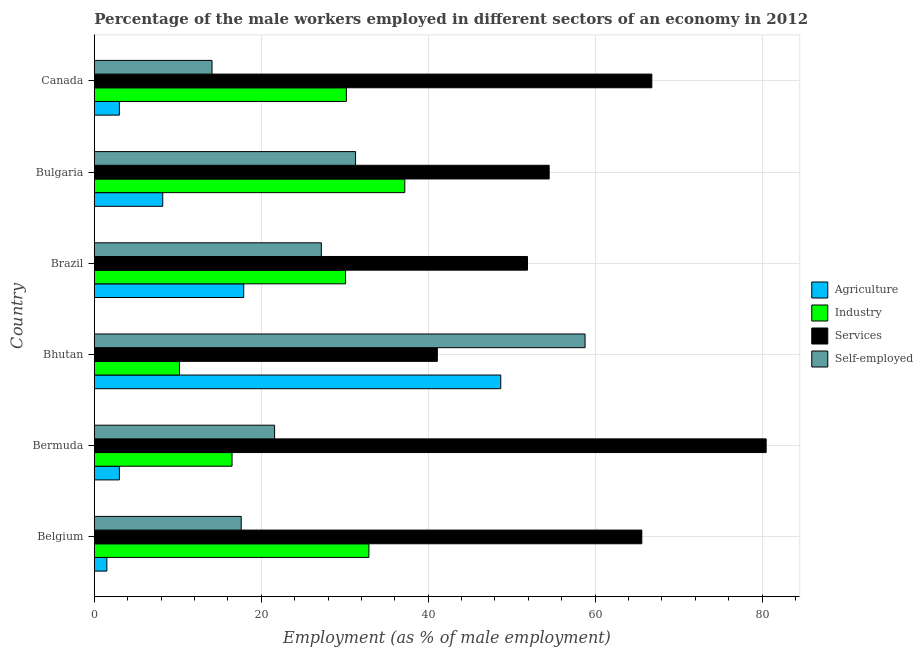How many different coloured bars are there?
Provide a succinct answer. 4. How many groups of bars are there?
Keep it short and to the point. 6. Are the number of bars on each tick of the Y-axis equal?
Provide a succinct answer. Yes. How many bars are there on the 6th tick from the top?
Provide a succinct answer. 4. What is the label of the 3rd group of bars from the top?
Your answer should be compact. Brazil. What is the percentage of male workers in industry in Bhutan?
Provide a short and direct response. 10.2. Across all countries, what is the maximum percentage of male workers in agriculture?
Your response must be concise. 48.7. Across all countries, what is the minimum percentage of male workers in services?
Keep it short and to the point. 41.1. In which country was the percentage of self employed male workers maximum?
Your response must be concise. Bhutan. In which country was the percentage of male workers in services minimum?
Your response must be concise. Bhutan. What is the total percentage of male workers in industry in the graph?
Make the answer very short. 157.1. What is the difference between the percentage of male workers in services in Bermuda and the percentage of self employed male workers in Canada?
Keep it short and to the point. 66.4. What is the average percentage of male workers in services per country?
Offer a terse response. 60.07. What is the difference between the percentage of male workers in services and percentage of male workers in industry in Belgium?
Make the answer very short. 32.7. What is the ratio of the percentage of self employed male workers in Bermuda to that in Canada?
Keep it short and to the point. 1.53. Is the percentage of self employed male workers in Bhutan less than that in Brazil?
Give a very brief answer. No. What is the difference between the highest and the second highest percentage of male workers in industry?
Offer a very short reply. 4.3. What is the difference between the highest and the lowest percentage of male workers in agriculture?
Offer a very short reply. 47.2. In how many countries, is the percentage of male workers in services greater than the average percentage of male workers in services taken over all countries?
Your answer should be compact. 3. Is it the case that in every country, the sum of the percentage of male workers in industry and percentage of male workers in agriculture is greater than the sum of percentage of male workers in services and percentage of self employed male workers?
Give a very brief answer. No. What does the 3rd bar from the top in Bhutan represents?
Make the answer very short. Industry. What does the 3rd bar from the bottom in Bulgaria represents?
Your response must be concise. Services. Is it the case that in every country, the sum of the percentage of male workers in agriculture and percentage of male workers in industry is greater than the percentage of male workers in services?
Your answer should be very brief. No. How many bars are there?
Keep it short and to the point. 24. Are all the bars in the graph horizontal?
Provide a succinct answer. Yes. How many countries are there in the graph?
Ensure brevity in your answer.  6. Does the graph contain grids?
Your answer should be compact. Yes. Where does the legend appear in the graph?
Ensure brevity in your answer.  Center right. How are the legend labels stacked?
Make the answer very short. Vertical. What is the title of the graph?
Offer a very short reply. Percentage of the male workers employed in different sectors of an economy in 2012. What is the label or title of the X-axis?
Give a very brief answer. Employment (as % of male employment). What is the label or title of the Y-axis?
Keep it short and to the point. Country. What is the Employment (as % of male employment) in Agriculture in Belgium?
Offer a very short reply. 1.5. What is the Employment (as % of male employment) of Industry in Belgium?
Your answer should be compact. 32.9. What is the Employment (as % of male employment) of Services in Belgium?
Your answer should be compact. 65.6. What is the Employment (as % of male employment) of Self-employed in Belgium?
Provide a short and direct response. 17.6. What is the Employment (as % of male employment) in Agriculture in Bermuda?
Ensure brevity in your answer.  3. What is the Employment (as % of male employment) in Services in Bermuda?
Offer a very short reply. 80.5. What is the Employment (as % of male employment) of Self-employed in Bermuda?
Offer a very short reply. 21.6. What is the Employment (as % of male employment) in Agriculture in Bhutan?
Ensure brevity in your answer.  48.7. What is the Employment (as % of male employment) in Industry in Bhutan?
Your response must be concise. 10.2. What is the Employment (as % of male employment) in Services in Bhutan?
Make the answer very short. 41.1. What is the Employment (as % of male employment) of Self-employed in Bhutan?
Your answer should be compact. 58.8. What is the Employment (as % of male employment) of Agriculture in Brazil?
Your response must be concise. 17.9. What is the Employment (as % of male employment) in Industry in Brazil?
Ensure brevity in your answer.  30.1. What is the Employment (as % of male employment) of Services in Brazil?
Provide a succinct answer. 51.9. What is the Employment (as % of male employment) in Self-employed in Brazil?
Provide a short and direct response. 27.2. What is the Employment (as % of male employment) in Agriculture in Bulgaria?
Provide a short and direct response. 8.2. What is the Employment (as % of male employment) of Industry in Bulgaria?
Offer a terse response. 37.2. What is the Employment (as % of male employment) of Services in Bulgaria?
Your answer should be compact. 54.5. What is the Employment (as % of male employment) of Self-employed in Bulgaria?
Keep it short and to the point. 31.3. What is the Employment (as % of male employment) in Industry in Canada?
Your answer should be very brief. 30.2. What is the Employment (as % of male employment) in Services in Canada?
Offer a terse response. 66.8. What is the Employment (as % of male employment) of Self-employed in Canada?
Ensure brevity in your answer.  14.1. Across all countries, what is the maximum Employment (as % of male employment) in Agriculture?
Your answer should be very brief. 48.7. Across all countries, what is the maximum Employment (as % of male employment) in Industry?
Your response must be concise. 37.2. Across all countries, what is the maximum Employment (as % of male employment) in Services?
Provide a short and direct response. 80.5. Across all countries, what is the maximum Employment (as % of male employment) of Self-employed?
Your answer should be compact. 58.8. Across all countries, what is the minimum Employment (as % of male employment) in Agriculture?
Offer a terse response. 1.5. Across all countries, what is the minimum Employment (as % of male employment) of Industry?
Make the answer very short. 10.2. Across all countries, what is the minimum Employment (as % of male employment) in Services?
Offer a terse response. 41.1. Across all countries, what is the minimum Employment (as % of male employment) of Self-employed?
Ensure brevity in your answer.  14.1. What is the total Employment (as % of male employment) in Agriculture in the graph?
Ensure brevity in your answer.  82.3. What is the total Employment (as % of male employment) of Industry in the graph?
Make the answer very short. 157.1. What is the total Employment (as % of male employment) of Services in the graph?
Provide a short and direct response. 360.4. What is the total Employment (as % of male employment) in Self-employed in the graph?
Your answer should be very brief. 170.6. What is the difference between the Employment (as % of male employment) in Agriculture in Belgium and that in Bermuda?
Ensure brevity in your answer.  -1.5. What is the difference between the Employment (as % of male employment) in Services in Belgium and that in Bermuda?
Ensure brevity in your answer.  -14.9. What is the difference between the Employment (as % of male employment) of Self-employed in Belgium and that in Bermuda?
Your answer should be very brief. -4. What is the difference between the Employment (as % of male employment) in Agriculture in Belgium and that in Bhutan?
Offer a terse response. -47.2. What is the difference between the Employment (as % of male employment) of Industry in Belgium and that in Bhutan?
Your answer should be compact. 22.7. What is the difference between the Employment (as % of male employment) of Self-employed in Belgium and that in Bhutan?
Make the answer very short. -41.2. What is the difference between the Employment (as % of male employment) of Agriculture in Belgium and that in Brazil?
Ensure brevity in your answer.  -16.4. What is the difference between the Employment (as % of male employment) in Services in Belgium and that in Brazil?
Make the answer very short. 13.7. What is the difference between the Employment (as % of male employment) of Agriculture in Belgium and that in Bulgaria?
Make the answer very short. -6.7. What is the difference between the Employment (as % of male employment) of Industry in Belgium and that in Bulgaria?
Your answer should be compact. -4.3. What is the difference between the Employment (as % of male employment) in Self-employed in Belgium and that in Bulgaria?
Give a very brief answer. -13.7. What is the difference between the Employment (as % of male employment) in Agriculture in Bermuda and that in Bhutan?
Provide a short and direct response. -45.7. What is the difference between the Employment (as % of male employment) in Industry in Bermuda and that in Bhutan?
Provide a succinct answer. 6.3. What is the difference between the Employment (as % of male employment) of Services in Bermuda and that in Bhutan?
Keep it short and to the point. 39.4. What is the difference between the Employment (as % of male employment) in Self-employed in Bermuda and that in Bhutan?
Your response must be concise. -37.2. What is the difference between the Employment (as % of male employment) in Agriculture in Bermuda and that in Brazil?
Your answer should be very brief. -14.9. What is the difference between the Employment (as % of male employment) of Services in Bermuda and that in Brazil?
Offer a terse response. 28.6. What is the difference between the Employment (as % of male employment) in Agriculture in Bermuda and that in Bulgaria?
Your response must be concise. -5.2. What is the difference between the Employment (as % of male employment) of Industry in Bermuda and that in Bulgaria?
Offer a very short reply. -20.7. What is the difference between the Employment (as % of male employment) in Industry in Bermuda and that in Canada?
Offer a terse response. -13.7. What is the difference between the Employment (as % of male employment) of Services in Bermuda and that in Canada?
Offer a very short reply. 13.7. What is the difference between the Employment (as % of male employment) in Agriculture in Bhutan and that in Brazil?
Your response must be concise. 30.8. What is the difference between the Employment (as % of male employment) in Industry in Bhutan and that in Brazil?
Keep it short and to the point. -19.9. What is the difference between the Employment (as % of male employment) in Services in Bhutan and that in Brazil?
Provide a succinct answer. -10.8. What is the difference between the Employment (as % of male employment) in Self-employed in Bhutan and that in Brazil?
Your answer should be compact. 31.6. What is the difference between the Employment (as % of male employment) in Agriculture in Bhutan and that in Bulgaria?
Give a very brief answer. 40.5. What is the difference between the Employment (as % of male employment) of Industry in Bhutan and that in Bulgaria?
Your response must be concise. -27. What is the difference between the Employment (as % of male employment) of Services in Bhutan and that in Bulgaria?
Your answer should be compact. -13.4. What is the difference between the Employment (as % of male employment) of Agriculture in Bhutan and that in Canada?
Keep it short and to the point. 45.7. What is the difference between the Employment (as % of male employment) of Industry in Bhutan and that in Canada?
Provide a succinct answer. -20. What is the difference between the Employment (as % of male employment) in Services in Bhutan and that in Canada?
Keep it short and to the point. -25.7. What is the difference between the Employment (as % of male employment) in Self-employed in Bhutan and that in Canada?
Offer a very short reply. 44.7. What is the difference between the Employment (as % of male employment) of Agriculture in Brazil and that in Canada?
Provide a succinct answer. 14.9. What is the difference between the Employment (as % of male employment) of Industry in Brazil and that in Canada?
Make the answer very short. -0.1. What is the difference between the Employment (as % of male employment) of Services in Brazil and that in Canada?
Offer a very short reply. -14.9. What is the difference between the Employment (as % of male employment) in Self-employed in Brazil and that in Canada?
Provide a short and direct response. 13.1. What is the difference between the Employment (as % of male employment) of Services in Bulgaria and that in Canada?
Offer a very short reply. -12.3. What is the difference between the Employment (as % of male employment) of Self-employed in Bulgaria and that in Canada?
Give a very brief answer. 17.2. What is the difference between the Employment (as % of male employment) of Agriculture in Belgium and the Employment (as % of male employment) of Industry in Bermuda?
Make the answer very short. -15. What is the difference between the Employment (as % of male employment) in Agriculture in Belgium and the Employment (as % of male employment) in Services in Bermuda?
Give a very brief answer. -79. What is the difference between the Employment (as % of male employment) of Agriculture in Belgium and the Employment (as % of male employment) of Self-employed in Bermuda?
Provide a succinct answer. -20.1. What is the difference between the Employment (as % of male employment) in Industry in Belgium and the Employment (as % of male employment) in Services in Bermuda?
Your response must be concise. -47.6. What is the difference between the Employment (as % of male employment) of Services in Belgium and the Employment (as % of male employment) of Self-employed in Bermuda?
Your answer should be compact. 44. What is the difference between the Employment (as % of male employment) in Agriculture in Belgium and the Employment (as % of male employment) in Services in Bhutan?
Keep it short and to the point. -39.6. What is the difference between the Employment (as % of male employment) in Agriculture in Belgium and the Employment (as % of male employment) in Self-employed in Bhutan?
Provide a short and direct response. -57.3. What is the difference between the Employment (as % of male employment) in Industry in Belgium and the Employment (as % of male employment) in Self-employed in Bhutan?
Your answer should be compact. -25.9. What is the difference between the Employment (as % of male employment) of Agriculture in Belgium and the Employment (as % of male employment) of Industry in Brazil?
Offer a terse response. -28.6. What is the difference between the Employment (as % of male employment) in Agriculture in Belgium and the Employment (as % of male employment) in Services in Brazil?
Provide a succinct answer. -50.4. What is the difference between the Employment (as % of male employment) in Agriculture in Belgium and the Employment (as % of male employment) in Self-employed in Brazil?
Provide a short and direct response. -25.7. What is the difference between the Employment (as % of male employment) of Industry in Belgium and the Employment (as % of male employment) of Services in Brazil?
Your answer should be compact. -19. What is the difference between the Employment (as % of male employment) in Industry in Belgium and the Employment (as % of male employment) in Self-employed in Brazil?
Make the answer very short. 5.7. What is the difference between the Employment (as % of male employment) in Services in Belgium and the Employment (as % of male employment) in Self-employed in Brazil?
Offer a very short reply. 38.4. What is the difference between the Employment (as % of male employment) of Agriculture in Belgium and the Employment (as % of male employment) of Industry in Bulgaria?
Your answer should be very brief. -35.7. What is the difference between the Employment (as % of male employment) in Agriculture in Belgium and the Employment (as % of male employment) in Services in Bulgaria?
Give a very brief answer. -53. What is the difference between the Employment (as % of male employment) of Agriculture in Belgium and the Employment (as % of male employment) of Self-employed in Bulgaria?
Offer a very short reply. -29.8. What is the difference between the Employment (as % of male employment) of Industry in Belgium and the Employment (as % of male employment) of Services in Bulgaria?
Make the answer very short. -21.6. What is the difference between the Employment (as % of male employment) in Services in Belgium and the Employment (as % of male employment) in Self-employed in Bulgaria?
Your answer should be compact. 34.3. What is the difference between the Employment (as % of male employment) in Agriculture in Belgium and the Employment (as % of male employment) in Industry in Canada?
Provide a short and direct response. -28.7. What is the difference between the Employment (as % of male employment) of Agriculture in Belgium and the Employment (as % of male employment) of Services in Canada?
Offer a terse response. -65.3. What is the difference between the Employment (as % of male employment) in Industry in Belgium and the Employment (as % of male employment) in Services in Canada?
Your response must be concise. -33.9. What is the difference between the Employment (as % of male employment) in Industry in Belgium and the Employment (as % of male employment) in Self-employed in Canada?
Provide a short and direct response. 18.8. What is the difference between the Employment (as % of male employment) in Services in Belgium and the Employment (as % of male employment) in Self-employed in Canada?
Keep it short and to the point. 51.5. What is the difference between the Employment (as % of male employment) of Agriculture in Bermuda and the Employment (as % of male employment) of Industry in Bhutan?
Your response must be concise. -7.2. What is the difference between the Employment (as % of male employment) of Agriculture in Bermuda and the Employment (as % of male employment) of Services in Bhutan?
Give a very brief answer. -38.1. What is the difference between the Employment (as % of male employment) in Agriculture in Bermuda and the Employment (as % of male employment) in Self-employed in Bhutan?
Ensure brevity in your answer.  -55.8. What is the difference between the Employment (as % of male employment) in Industry in Bermuda and the Employment (as % of male employment) in Services in Bhutan?
Your response must be concise. -24.6. What is the difference between the Employment (as % of male employment) of Industry in Bermuda and the Employment (as % of male employment) of Self-employed in Bhutan?
Offer a terse response. -42.3. What is the difference between the Employment (as % of male employment) in Services in Bermuda and the Employment (as % of male employment) in Self-employed in Bhutan?
Keep it short and to the point. 21.7. What is the difference between the Employment (as % of male employment) of Agriculture in Bermuda and the Employment (as % of male employment) of Industry in Brazil?
Keep it short and to the point. -27.1. What is the difference between the Employment (as % of male employment) of Agriculture in Bermuda and the Employment (as % of male employment) of Services in Brazil?
Make the answer very short. -48.9. What is the difference between the Employment (as % of male employment) in Agriculture in Bermuda and the Employment (as % of male employment) in Self-employed in Brazil?
Make the answer very short. -24.2. What is the difference between the Employment (as % of male employment) in Industry in Bermuda and the Employment (as % of male employment) in Services in Brazil?
Offer a terse response. -35.4. What is the difference between the Employment (as % of male employment) of Services in Bermuda and the Employment (as % of male employment) of Self-employed in Brazil?
Provide a succinct answer. 53.3. What is the difference between the Employment (as % of male employment) of Agriculture in Bermuda and the Employment (as % of male employment) of Industry in Bulgaria?
Your response must be concise. -34.2. What is the difference between the Employment (as % of male employment) in Agriculture in Bermuda and the Employment (as % of male employment) in Services in Bulgaria?
Your response must be concise. -51.5. What is the difference between the Employment (as % of male employment) in Agriculture in Bermuda and the Employment (as % of male employment) in Self-employed in Bulgaria?
Provide a succinct answer. -28.3. What is the difference between the Employment (as % of male employment) in Industry in Bermuda and the Employment (as % of male employment) in Services in Bulgaria?
Keep it short and to the point. -38. What is the difference between the Employment (as % of male employment) of Industry in Bermuda and the Employment (as % of male employment) of Self-employed in Bulgaria?
Provide a succinct answer. -14.8. What is the difference between the Employment (as % of male employment) in Services in Bermuda and the Employment (as % of male employment) in Self-employed in Bulgaria?
Provide a succinct answer. 49.2. What is the difference between the Employment (as % of male employment) in Agriculture in Bermuda and the Employment (as % of male employment) in Industry in Canada?
Make the answer very short. -27.2. What is the difference between the Employment (as % of male employment) of Agriculture in Bermuda and the Employment (as % of male employment) of Services in Canada?
Provide a short and direct response. -63.8. What is the difference between the Employment (as % of male employment) in Industry in Bermuda and the Employment (as % of male employment) in Services in Canada?
Give a very brief answer. -50.3. What is the difference between the Employment (as % of male employment) in Industry in Bermuda and the Employment (as % of male employment) in Self-employed in Canada?
Give a very brief answer. 2.4. What is the difference between the Employment (as % of male employment) of Services in Bermuda and the Employment (as % of male employment) of Self-employed in Canada?
Offer a terse response. 66.4. What is the difference between the Employment (as % of male employment) in Industry in Bhutan and the Employment (as % of male employment) in Services in Brazil?
Provide a succinct answer. -41.7. What is the difference between the Employment (as % of male employment) in Industry in Bhutan and the Employment (as % of male employment) in Self-employed in Brazil?
Keep it short and to the point. -17. What is the difference between the Employment (as % of male employment) in Services in Bhutan and the Employment (as % of male employment) in Self-employed in Brazil?
Your response must be concise. 13.9. What is the difference between the Employment (as % of male employment) in Agriculture in Bhutan and the Employment (as % of male employment) in Self-employed in Bulgaria?
Provide a succinct answer. 17.4. What is the difference between the Employment (as % of male employment) of Industry in Bhutan and the Employment (as % of male employment) of Services in Bulgaria?
Your response must be concise. -44.3. What is the difference between the Employment (as % of male employment) in Industry in Bhutan and the Employment (as % of male employment) in Self-employed in Bulgaria?
Provide a short and direct response. -21.1. What is the difference between the Employment (as % of male employment) of Agriculture in Bhutan and the Employment (as % of male employment) of Industry in Canada?
Make the answer very short. 18.5. What is the difference between the Employment (as % of male employment) of Agriculture in Bhutan and the Employment (as % of male employment) of Services in Canada?
Offer a terse response. -18.1. What is the difference between the Employment (as % of male employment) of Agriculture in Bhutan and the Employment (as % of male employment) of Self-employed in Canada?
Offer a very short reply. 34.6. What is the difference between the Employment (as % of male employment) in Industry in Bhutan and the Employment (as % of male employment) in Services in Canada?
Offer a terse response. -56.6. What is the difference between the Employment (as % of male employment) in Industry in Bhutan and the Employment (as % of male employment) in Self-employed in Canada?
Your answer should be compact. -3.9. What is the difference between the Employment (as % of male employment) in Services in Bhutan and the Employment (as % of male employment) in Self-employed in Canada?
Keep it short and to the point. 27. What is the difference between the Employment (as % of male employment) of Agriculture in Brazil and the Employment (as % of male employment) of Industry in Bulgaria?
Offer a very short reply. -19.3. What is the difference between the Employment (as % of male employment) of Agriculture in Brazil and the Employment (as % of male employment) of Services in Bulgaria?
Provide a short and direct response. -36.6. What is the difference between the Employment (as % of male employment) in Industry in Brazil and the Employment (as % of male employment) in Services in Bulgaria?
Your answer should be very brief. -24.4. What is the difference between the Employment (as % of male employment) of Industry in Brazil and the Employment (as % of male employment) of Self-employed in Bulgaria?
Provide a succinct answer. -1.2. What is the difference between the Employment (as % of male employment) in Services in Brazil and the Employment (as % of male employment) in Self-employed in Bulgaria?
Provide a succinct answer. 20.6. What is the difference between the Employment (as % of male employment) in Agriculture in Brazil and the Employment (as % of male employment) in Industry in Canada?
Make the answer very short. -12.3. What is the difference between the Employment (as % of male employment) of Agriculture in Brazil and the Employment (as % of male employment) of Services in Canada?
Provide a short and direct response. -48.9. What is the difference between the Employment (as % of male employment) of Agriculture in Brazil and the Employment (as % of male employment) of Self-employed in Canada?
Ensure brevity in your answer.  3.8. What is the difference between the Employment (as % of male employment) in Industry in Brazil and the Employment (as % of male employment) in Services in Canada?
Your response must be concise. -36.7. What is the difference between the Employment (as % of male employment) of Industry in Brazil and the Employment (as % of male employment) of Self-employed in Canada?
Your response must be concise. 16. What is the difference between the Employment (as % of male employment) in Services in Brazil and the Employment (as % of male employment) in Self-employed in Canada?
Provide a short and direct response. 37.8. What is the difference between the Employment (as % of male employment) in Agriculture in Bulgaria and the Employment (as % of male employment) in Services in Canada?
Provide a short and direct response. -58.6. What is the difference between the Employment (as % of male employment) in Industry in Bulgaria and the Employment (as % of male employment) in Services in Canada?
Your answer should be compact. -29.6. What is the difference between the Employment (as % of male employment) of Industry in Bulgaria and the Employment (as % of male employment) of Self-employed in Canada?
Offer a very short reply. 23.1. What is the difference between the Employment (as % of male employment) in Services in Bulgaria and the Employment (as % of male employment) in Self-employed in Canada?
Your answer should be very brief. 40.4. What is the average Employment (as % of male employment) in Agriculture per country?
Your answer should be compact. 13.72. What is the average Employment (as % of male employment) of Industry per country?
Provide a succinct answer. 26.18. What is the average Employment (as % of male employment) in Services per country?
Offer a very short reply. 60.07. What is the average Employment (as % of male employment) in Self-employed per country?
Give a very brief answer. 28.43. What is the difference between the Employment (as % of male employment) in Agriculture and Employment (as % of male employment) in Industry in Belgium?
Keep it short and to the point. -31.4. What is the difference between the Employment (as % of male employment) in Agriculture and Employment (as % of male employment) in Services in Belgium?
Ensure brevity in your answer.  -64.1. What is the difference between the Employment (as % of male employment) in Agriculture and Employment (as % of male employment) in Self-employed in Belgium?
Your answer should be compact. -16.1. What is the difference between the Employment (as % of male employment) of Industry and Employment (as % of male employment) of Services in Belgium?
Offer a very short reply. -32.7. What is the difference between the Employment (as % of male employment) of Industry and Employment (as % of male employment) of Self-employed in Belgium?
Your response must be concise. 15.3. What is the difference between the Employment (as % of male employment) of Services and Employment (as % of male employment) of Self-employed in Belgium?
Offer a very short reply. 48. What is the difference between the Employment (as % of male employment) of Agriculture and Employment (as % of male employment) of Services in Bermuda?
Offer a very short reply. -77.5. What is the difference between the Employment (as % of male employment) of Agriculture and Employment (as % of male employment) of Self-employed in Bermuda?
Keep it short and to the point. -18.6. What is the difference between the Employment (as % of male employment) in Industry and Employment (as % of male employment) in Services in Bermuda?
Your answer should be compact. -64. What is the difference between the Employment (as % of male employment) in Services and Employment (as % of male employment) in Self-employed in Bermuda?
Keep it short and to the point. 58.9. What is the difference between the Employment (as % of male employment) of Agriculture and Employment (as % of male employment) of Industry in Bhutan?
Offer a very short reply. 38.5. What is the difference between the Employment (as % of male employment) in Agriculture and Employment (as % of male employment) in Services in Bhutan?
Provide a succinct answer. 7.6. What is the difference between the Employment (as % of male employment) in Agriculture and Employment (as % of male employment) in Self-employed in Bhutan?
Your answer should be very brief. -10.1. What is the difference between the Employment (as % of male employment) in Industry and Employment (as % of male employment) in Services in Bhutan?
Ensure brevity in your answer.  -30.9. What is the difference between the Employment (as % of male employment) in Industry and Employment (as % of male employment) in Self-employed in Bhutan?
Your answer should be compact. -48.6. What is the difference between the Employment (as % of male employment) of Services and Employment (as % of male employment) of Self-employed in Bhutan?
Provide a succinct answer. -17.7. What is the difference between the Employment (as % of male employment) in Agriculture and Employment (as % of male employment) in Industry in Brazil?
Offer a terse response. -12.2. What is the difference between the Employment (as % of male employment) in Agriculture and Employment (as % of male employment) in Services in Brazil?
Make the answer very short. -34. What is the difference between the Employment (as % of male employment) of Agriculture and Employment (as % of male employment) of Self-employed in Brazil?
Provide a short and direct response. -9.3. What is the difference between the Employment (as % of male employment) in Industry and Employment (as % of male employment) in Services in Brazil?
Your response must be concise. -21.8. What is the difference between the Employment (as % of male employment) of Services and Employment (as % of male employment) of Self-employed in Brazil?
Keep it short and to the point. 24.7. What is the difference between the Employment (as % of male employment) of Agriculture and Employment (as % of male employment) of Services in Bulgaria?
Provide a succinct answer. -46.3. What is the difference between the Employment (as % of male employment) of Agriculture and Employment (as % of male employment) of Self-employed in Bulgaria?
Offer a very short reply. -23.1. What is the difference between the Employment (as % of male employment) of Industry and Employment (as % of male employment) of Services in Bulgaria?
Make the answer very short. -17.3. What is the difference between the Employment (as % of male employment) of Services and Employment (as % of male employment) of Self-employed in Bulgaria?
Offer a terse response. 23.2. What is the difference between the Employment (as % of male employment) in Agriculture and Employment (as % of male employment) in Industry in Canada?
Give a very brief answer. -27.2. What is the difference between the Employment (as % of male employment) in Agriculture and Employment (as % of male employment) in Services in Canada?
Your answer should be compact. -63.8. What is the difference between the Employment (as % of male employment) of Industry and Employment (as % of male employment) of Services in Canada?
Offer a terse response. -36.6. What is the difference between the Employment (as % of male employment) in Services and Employment (as % of male employment) in Self-employed in Canada?
Keep it short and to the point. 52.7. What is the ratio of the Employment (as % of male employment) in Industry in Belgium to that in Bermuda?
Provide a short and direct response. 1.99. What is the ratio of the Employment (as % of male employment) of Services in Belgium to that in Bermuda?
Offer a terse response. 0.81. What is the ratio of the Employment (as % of male employment) in Self-employed in Belgium to that in Bermuda?
Provide a succinct answer. 0.81. What is the ratio of the Employment (as % of male employment) of Agriculture in Belgium to that in Bhutan?
Keep it short and to the point. 0.03. What is the ratio of the Employment (as % of male employment) of Industry in Belgium to that in Bhutan?
Make the answer very short. 3.23. What is the ratio of the Employment (as % of male employment) in Services in Belgium to that in Bhutan?
Ensure brevity in your answer.  1.6. What is the ratio of the Employment (as % of male employment) in Self-employed in Belgium to that in Bhutan?
Provide a succinct answer. 0.3. What is the ratio of the Employment (as % of male employment) in Agriculture in Belgium to that in Brazil?
Offer a terse response. 0.08. What is the ratio of the Employment (as % of male employment) of Industry in Belgium to that in Brazil?
Keep it short and to the point. 1.09. What is the ratio of the Employment (as % of male employment) of Services in Belgium to that in Brazil?
Give a very brief answer. 1.26. What is the ratio of the Employment (as % of male employment) in Self-employed in Belgium to that in Brazil?
Your answer should be compact. 0.65. What is the ratio of the Employment (as % of male employment) of Agriculture in Belgium to that in Bulgaria?
Make the answer very short. 0.18. What is the ratio of the Employment (as % of male employment) of Industry in Belgium to that in Bulgaria?
Keep it short and to the point. 0.88. What is the ratio of the Employment (as % of male employment) in Services in Belgium to that in Bulgaria?
Your answer should be very brief. 1.2. What is the ratio of the Employment (as % of male employment) in Self-employed in Belgium to that in Bulgaria?
Your answer should be compact. 0.56. What is the ratio of the Employment (as % of male employment) in Industry in Belgium to that in Canada?
Make the answer very short. 1.09. What is the ratio of the Employment (as % of male employment) of Self-employed in Belgium to that in Canada?
Provide a short and direct response. 1.25. What is the ratio of the Employment (as % of male employment) of Agriculture in Bermuda to that in Bhutan?
Make the answer very short. 0.06. What is the ratio of the Employment (as % of male employment) of Industry in Bermuda to that in Bhutan?
Make the answer very short. 1.62. What is the ratio of the Employment (as % of male employment) in Services in Bermuda to that in Bhutan?
Your answer should be compact. 1.96. What is the ratio of the Employment (as % of male employment) in Self-employed in Bermuda to that in Bhutan?
Offer a terse response. 0.37. What is the ratio of the Employment (as % of male employment) in Agriculture in Bermuda to that in Brazil?
Make the answer very short. 0.17. What is the ratio of the Employment (as % of male employment) of Industry in Bermuda to that in Brazil?
Provide a succinct answer. 0.55. What is the ratio of the Employment (as % of male employment) of Services in Bermuda to that in Brazil?
Make the answer very short. 1.55. What is the ratio of the Employment (as % of male employment) of Self-employed in Bermuda to that in Brazil?
Give a very brief answer. 0.79. What is the ratio of the Employment (as % of male employment) of Agriculture in Bermuda to that in Bulgaria?
Make the answer very short. 0.37. What is the ratio of the Employment (as % of male employment) in Industry in Bermuda to that in Bulgaria?
Your response must be concise. 0.44. What is the ratio of the Employment (as % of male employment) of Services in Bermuda to that in Bulgaria?
Provide a short and direct response. 1.48. What is the ratio of the Employment (as % of male employment) of Self-employed in Bermuda to that in Bulgaria?
Provide a short and direct response. 0.69. What is the ratio of the Employment (as % of male employment) of Agriculture in Bermuda to that in Canada?
Keep it short and to the point. 1. What is the ratio of the Employment (as % of male employment) in Industry in Bermuda to that in Canada?
Ensure brevity in your answer.  0.55. What is the ratio of the Employment (as % of male employment) of Services in Bermuda to that in Canada?
Your answer should be very brief. 1.21. What is the ratio of the Employment (as % of male employment) of Self-employed in Bermuda to that in Canada?
Ensure brevity in your answer.  1.53. What is the ratio of the Employment (as % of male employment) of Agriculture in Bhutan to that in Brazil?
Offer a very short reply. 2.72. What is the ratio of the Employment (as % of male employment) in Industry in Bhutan to that in Brazil?
Give a very brief answer. 0.34. What is the ratio of the Employment (as % of male employment) of Services in Bhutan to that in Brazil?
Your answer should be very brief. 0.79. What is the ratio of the Employment (as % of male employment) of Self-employed in Bhutan to that in Brazil?
Your response must be concise. 2.16. What is the ratio of the Employment (as % of male employment) of Agriculture in Bhutan to that in Bulgaria?
Provide a short and direct response. 5.94. What is the ratio of the Employment (as % of male employment) in Industry in Bhutan to that in Bulgaria?
Provide a succinct answer. 0.27. What is the ratio of the Employment (as % of male employment) in Services in Bhutan to that in Bulgaria?
Give a very brief answer. 0.75. What is the ratio of the Employment (as % of male employment) in Self-employed in Bhutan to that in Bulgaria?
Your response must be concise. 1.88. What is the ratio of the Employment (as % of male employment) in Agriculture in Bhutan to that in Canada?
Your answer should be compact. 16.23. What is the ratio of the Employment (as % of male employment) of Industry in Bhutan to that in Canada?
Give a very brief answer. 0.34. What is the ratio of the Employment (as % of male employment) of Services in Bhutan to that in Canada?
Your answer should be very brief. 0.62. What is the ratio of the Employment (as % of male employment) in Self-employed in Bhutan to that in Canada?
Your response must be concise. 4.17. What is the ratio of the Employment (as % of male employment) of Agriculture in Brazil to that in Bulgaria?
Keep it short and to the point. 2.18. What is the ratio of the Employment (as % of male employment) of Industry in Brazil to that in Bulgaria?
Ensure brevity in your answer.  0.81. What is the ratio of the Employment (as % of male employment) in Services in Brazil to that in Bulgaria?
Offer a terse response. 0.95. What is the ratio of the Employment (as % of male employment) in Self-employed in Brazil to that in Bulgaria?
Provide a succinct answer. 0.87. What is the ratio of the Employment (as % of male employment) in Agriculture in Brazil to that in Canada?
Give a very brief answer. 5.97. What is the ratio of the Employment (as % of male employment) in Industry in Brazil to that in Canada?
Keep it short and to the point. 1. What is the ratio of the Employment (as % of male employment) in Services in Brazil to that in Canada?
Give a very brief answer. 0.78. What is the ratio of the Employment (as % of male employment) of Self-employed in Brazil to that in Canada?
Offer a terse response. 1.93. What is the ratio of the Employment (as % of male employment) of Agriculture in Bulgaria to that in Canada?
Provide a short and direct response. 2.73. What is the ratio of the Employment (as % of male employment) in Industry in Bulgaria to that in Canada?
Your answer should be compact. 1.23. What is the ratio of the Employment (as % of male employment) in Services in Bulgaria to that in Canada?
Provide a short and direct response. 0.82. What is the ratio of the Employment (as % of male employment) in Self-employed in Bulgaria to that in Canada?
Provide a succinct answer. 2.22. What is the difference between the highest and the second highest Employment (as % of male employment) of Agriculture?
Make the answer very short. 30.8. What is the difference between the highest and the second highest Employment (as % of male employment) of Services?
Offer a very short reply. 13.7. What is the difference between the highest and the second highest Employment (as % of male employment) in Self-employed?
Your response must be concise. 27.5. What is the difference between the highest and the lowest Employment (as % of male employment) of Agriculture?
Provide a short and direct response. 47.2. What is the difference between the highest and the lowest Employment (as % of male employment) in Services?
Offer a terse response. 39.4. What is the difference between the highest and the lowest Employment (as % of male employment) in Self-employed?
Your answer should be very brief. 44.7. 